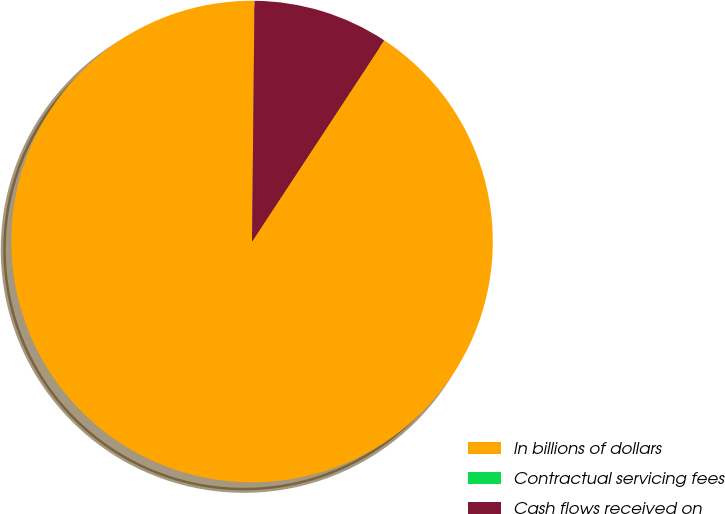<chart> <loc_0><loc_0><loc_500><loc_500><pie_chart><fcel>In billions of dollars<fcel>Contractual servicing fees<fcel>Cash flows received on<nl><fcel>90.9%<fcel>0.0%<fcel>9.09%<nl></chart> 